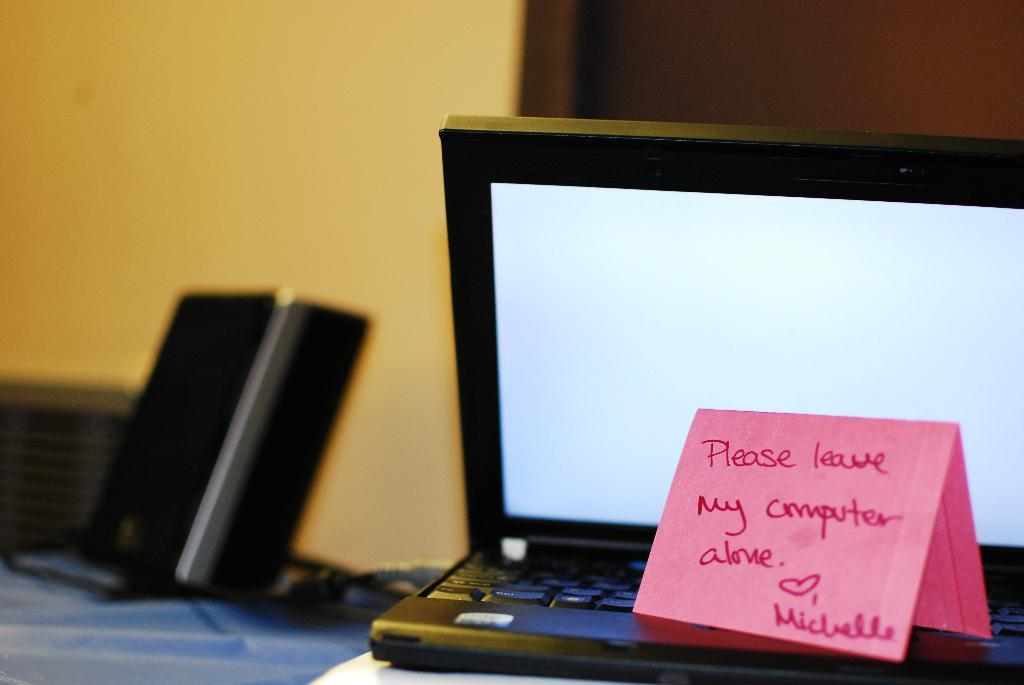<image>
Render a clear and concise summary of the photo. A notebook with a pink sign reading Please Leave My Computer Alone. 